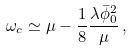<formula> <loc_0><loc_0><loc_500><loc_500>\omega _ { c } \simeq \mu - \frac { 1 } { 8 } \frac { \lambda \bar { \phi } _ { 0 } ^ { 2 } } { \mu } \, ,</formula> 